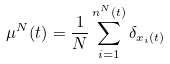<formula> <loc_0><loc_0><loc_500><loc_500>\mu ^ { N } ( t ) = \frac { 1 } { N } \sum _ { i = 1 } ^ { n ^ { N } ( t ) } \delta _ { x _ { i } ( t ) }</formula> 